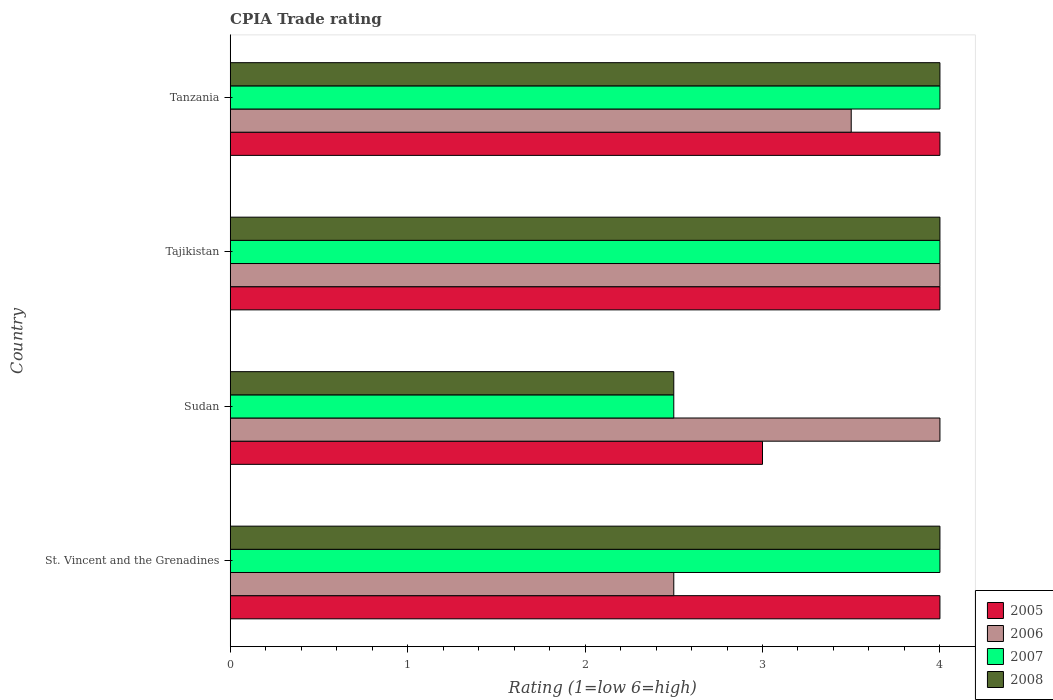How many groups of bars are there?
Give a very brief answer. 4. Are the number of bars per tick equal to the number of legend labels?
Your response must be concise. Yes. Are the number of bars on each tick of the Y-axis equal?
Provide a succinct answer. Yes. How many bars are there on the 1st tick from the bottom?
Offer a very short reply. 4. What is the label of the 3rd group of bars from the top?
Your response must be concise. Sudan. In how many cases, is the number of bars for a given country not equal to the number of legend labels?
Offer a very short reply. 0. What is the CPIA rating in 2007 in Tanzania?
Your response must be concise. 4. Across all countries, what is the maximum CPIA rating in 2007?
Ensure brevity in your answer.  4. In which country was the CPIA rating in 2006 maximum?
Your response must be concise. Sudan. In which country was the CPIA rating in 2005 minimum?
Ensure brevity in your answer.  Sudan. What is the difference between the CPIA rating in 2005 in Tajikistan and that in Tanzania?
Offer a very short reply. 0. What is the difference between the CPIA rating in 2006 in St. Vincent and the Grenadines and the CPIA rating in 2007 in Tanzania?
Offer a terse response. -1.5. What is the average CPIA rating in 2005 per country?
Your answer should be very brief. 3.75. What is the ratio of the CPIA rating in 2005 in Sudan to that in Tajikistan?
Give a very brief answer. 0.75. What is the difference between the highest and the lowest CPIA rating in 2008?
Provide a short and direct response. 1.5. Is it the case that in every country, the sum of the CPIA rating in 2005 and CPIA rating in 2006 is greater than the CPIA rating in 2008?
Give a very brief answer. Yes. How many bars are there?
Offer a terse response. 16. Are all the bars in the graph horizontal?
Provide a succinct answer. Yes. What is the difference between two consecutive major ticks on the X-axis?
Provide a succinct answer. 1. Are the values on the major ticks of X-axis written in scientific E-notation?
Ensure brevity in your answer.  No. Does the graph contain any zero values?
Your answer should be compact. No. How many legend labels are there?
Ensure brevity in your answer.  4. What is the title of the graph?
Provide a succinct answer. CPIA Trade rating. What is the label or title of the X-axis?
Provide a succinct answer. Rating (1=low 6=high). What is the Rating (1=low 6=high) of 2007 in Sudan?
Keep it short and to the point. 2.5. What is the Rating (1=low 6=high) in 2008 in Sudan?
Your response must be concise. 2.5. What is the Rating (1=low 6=high) in 2005 in Tajikistan?
Your response must be concise. 4. What is the Rating (1=low 6=high) of 2007 in Tajikistan?
Offer a terse response. 4. What is the Rating (1=low 6=high) of 2008 in Tajikistan?
Ensure brevity in your answer.  4. What is the Rating (1=low 6=high) in 2008 in Tanzania?
Your answer should be compact. 4. Across all countries, what is the maximum Rating (1=low 6=high) in 2005?
Provide a succinct answer. 4. Across all countries, what is the maximum Rating (1=low 6=high) of 2007?
Your answer should be very brief. 4. Across all countries, what is the minimum Rating (1=low 6=high) of 2006?
Ensure brevity in your answer.  2.5. What is the total Rating (1=low 6=high) of 2005 in the graph?
Provide a short and direct response. 15. What is the total Rating (1=low 6=high) of 2006 in the graph?
Your response must be concise. 14. What is the difference between the Rating (1=low 6=high) in 2006 in St. Vincent and the Grenadines and that in Sudan?
Provide a short and direct response. -1.5. What is the difference between the Rating (1=low 6=high) in 2008 in St. Vincent and the Grenadines and that in Tajikistan?
Make the answer very short. 0. What is the difference between the Rating (1=low 6=high) in 2006 in St. Vincent and the Grenadines and that in Tanzania?
Provide a succinct answer. -1. What is the difference between the Rating (1=low 6=high) of 2007 in St. Vincent and the Grenadines and that in Tanzania?
Offer a terse response. 0. What is the difference between the Rating (1=low 6=high) in 2005 in Sudan and that in Tajikistan?
Provide a short and direct response. -1. What is the difference between the Rating (1=low 6=high) in 2006 in Sudan and that in Tajikistan?
Give a very brief answer. 0. What is the difference between the Rating (1=low 6=high) in 2007 in Sudan and that in Tajikistan?
Provide a short and direct response. -1.5. What is the difference between the Rating (1=low 6=high) in 2008 in Sudan and that in Tajikistan?
Provide a short and direct response. -1.5. What is the difference between the Rating (1=low 6=high) of 2007 in Sudan and that in Tanzania?
Your answer should be very brief. -1.5. What is the difference between the Rating (1=low 6=high) in 2008 in Sudan and that in Tanzania?
Your response must be concise. -1.5. What is the difference between the Rating (1=low 6=high) of 2006 in Tajikistan and that in Tanzania?
Your answer should be compact. 0.5. What is the difference between the Rating (1=low 6=high) in 2007 in Tajikistan and that in Tanzania?
Provide a succinct answer. 0. What is the difference between the Rating (1=low 6=high) of 2008 in Tajikistan and that in Tanzania?
Provide a succinct answer. 0. What is the difference between the Rating (1=low 6=high) in 2005 in St. Vincent and the Grenadines and the Rating (1=low 6=high) in 2008 in Sudan?
Your answer should be compact. 1.5. What is the difference between the Rating (1=low 6=high) of 2006 in St. Vincent and the Grenadines and the Rating (1=low 6=high) of 2007 in Sudan?
Your answer should be very brief. 0. What is the difference between the Rating (1=low 6=high) of 2006 in St. Vincent and the Grenadines and the Rating (1=low 6=high) of 2008 in Sudan?
Make the answer very short. 0. What is the difference between the Rating (1=low 6=high) in 2007 in St. Vincent and the Grenadines and the Rating (1=low 6=high) in 2008 in Sudan?
Ensure brevity in your answer.  1.5. What is the difference between the Rating (1=low 6=high) of 2005 in St. Vincent and the Grenadines and the Rating (1=low 6=high) of 2007 in Tajikistan?
Offer a terse response. 0. What is the difference between the Rating (1=low 6=high) of 2006 in St. Vincent and the Grenadines and the Rating (1=low 6=high) of 2007 in Tajikistan?
Your answer should be compact. -1.5. What is the difference between the Rating (1=low 6=high) in 2005 in St. Vincent and the Grenadines and the Rating (1=low 6=high) in 2006 in Tanzania?
Ensure brevity in your answer.  0.5. What is the difference between the Rating (1=low 6=high) in 2005 in St. Vincent and the Grenadines and the Rating (1=low 6=high) in 2007 in Tanzania?
Give a very brief answer. 0. What is the difference between the Rating (1=low 6=high) of 2006 in St. Vincent and the Grenadines and the Rating (1=low 6=high) of 2007 in Tanzania?
Make the answer very short. -1.5. What is the difference between the Rating (1=low 6=high) in 2006 in St. Vincent and the Grenadines and the Rating (1=low 6=high) in 2008 in Tanzania?
Provide a succinct answer. -1.5. What is the difference between the Rating (1=low 6=high) of 2007 in St. Vincent and the Grenadines and the Rating (1=low 6=high) of 2008 in Tanzania?
Ensure brevity in your answer.  0. What is the difference between the Rating (1=low 6=high) in 2005 in Sudan and the Rating (1=low 6=high) in 2006 in Tajikistan?
Your response must be concise. -1. What is the difference between the Rating (1=low 6=high) in 2005 in Sudan and the Rating (1=low 6=high) in 2007 in Tajikistan?
Give a very brief answer. -1. What is the difference between the Rating (1=low 6=high) in 2006 in Sudan and the Rating (1=low 6=high) in 2007 in Tajikistan?
Your response must be concise. 0. What is the difference between the Rating (1=low 6=high) of 2006 in Sudan and the Rating (1=low 6=high) of 2008 in Tajikistan?
Offer a very short reply. 0. What is the difference between the Rating (1=low 6=high) of 2007 in Sudan and the Rating (1=low 6=high) of 2008 in Tajikistan?
Your answer should be compact. -1.5. What is the difference between the Rating (1=low 6=high) in 2006 in Sudan and the Rating (1=low 6=high) in 2008 in Tanzania?
Your answer should be compact. 0. What is the difference between the Rating (1=low 6=high) in 2005 in Tajikistan and the Rating (1=low 6=high) in 2007 in Tanzania?
Provide a short and direct response. 0. What is the difference between the Rating (1=low 6=high) of 2006 in Tajikistan and the Rating (1=low 6=high) of 2007 in Tanzania?
Provide a succinct answer. 0. What is the difference between the Rating (1=low 6=high) of 2006 in Tajikistan and the Rating (1=low 6=high) of 2008 in Tanzania?
Provide a short and direct response. 0. What is the average Rating (1=low 6=high) in 2005 per country?
Your answer should be very brief. 3.75. What is the average Rating (1=low 6=high) of 2006 per country?
Keep it short and to the point. 3.5. What is the average Rating (1=low 6=high) in 2007 per country?
Your answer should be compact. 3.62. What is the average Rating (1=low 6=high) of 2008 per country?
Offer a terse response. 3.62. What is the difference between the Rating (1=low 6=high) of 2005 and Rating (1=low 6=high) of 2007 in St. Vincent and the Grenadines?
Your answer should be compact. 0. What is the difference between the Rating (1=low 6=high) in 2005 and Rating (1=low 6=high) in 2008 in St. Vincent and the Grenadines?
Ensure brevity in your answer.  0. What is the difference between the Rating (1=low 6=high) in 2007 and Rating (1=low 6=high) in 2008 in St. Vincent and the Grenadines?
Keep it short and to the point. 0. What is the difference between the Rating (1=low 6=high) of 2005 and Rating (1=low 6=high) of 2006 in Sudan?
Provide a short and direct response. -1. What is the difference between the Rating (1=low 6=high) in 2006 and Rating (1=low 6=high) in 2008 in Sudan?
Your answer should be very brief. 1.5. What is the difference between the Rating (1=low 6=high) in 2007 and Rating (1=low 6=high) in 2008 in Sudan?
Offer a very short reply. 0. What is the difference between the Rating (1=low 6=high) in 2005 and Rating (1=low 6=high) in 2007 in Tajikistan?
Make the answer very short. 0. What is the difference between the Rating (1=low 6=high) of 2005 and Rating (1=low 6=high) of 2008 in Tajikistan?
Ensure brevity in your answer.  0. What is the difference between the Rating (1=low 6=high) of 2006 and Rating (1=low 6=high) of 2008 in Tajikistan?
Your response must be concise. 0. What is the difference between the Rating (1=low 6=high) in 2007 and Rating (1=low 6=high) in 2008 in Tajikistan?
Make the answer very short. 0. What is the difference between the Rating (1=low 6=high) in 2005 and Rating (1=low 6=high) in 2006 in Tanzania?
Give a very brief answer. 0.5. What is the difference between the Rating (1=low 6=high) of 2005 and Rating (1=low 6=high) of 2007 in Tanzania?
Your response must be concise. 0. What is the difference between the Rating (1=low 6=high) in 2005 and Rating (1=low 6=high) in 2008 in Tanzania?
Your answer should be very brief. 0. What is the difference between the Rating (1=low 6=high) of 2006 and Rating (1=low 6=high) of 2007 in Tanzania?
Your response must be concise. -0.5. What is the ratio of the Rating (1=low 6=high) in 2005 in St. Vincent and the Grenadines to that in Sudan?
Provide a succinct answer. 1.33. What is the ratio of the Rating (1=low 6=high) of 2006 in St. Vincent and the Grenadines to that in Tajikistan?
Offer a very short reply. 0.62. What is the ratio of the Rating (1=low 6=high) of 2007 in St. Vincent and the Grenadines to that in Tajikistan?
Keep it short and to the point. 1. What is the ratio of the Rating (1=low 6=high) in 2008 in St. Vincent and the Grenadines to that in Tajikistan?
Provide a short and direct response. 1. What is the ratio of the Rating (1=low 6=high) in 2005 in St. Vincent and the Grenadines to that in Tanzania?
Your answer should be very brief. 1. What is the ratio of the Rating (1=low 6=high) of 2007 in St. Vincent and the Grenadines to that in Tanzania?
Ensure brevity in your answer.  1. What is the ratio of the Rating (1=low 6=high) in 2008 in St. Vincent and the Grenadines to that in Tanzania?
Your answer should be compact. 1. What is the ratio of the Rating (1=low 6=high) in 2008 in Sudan to that in Tajikistan?
Give a very brief answer. 0.62. What is the ratio of the Rating (1=low 6=high) in 2005 in Sudan to that in Tanzania?
Keep it short and to the point. 0.75. What is the ratio of the Rating (1=low 6=high) in 2007 in Sudan to that in Tanzania?
Your response must be concise. 0.62. What is the ratio of the Rating (1=low 6=high) of 2008 in Sudan to that in Tanzania?
Offer a terse response. 0.62. What is the ratio of the Rating (1=low 6=high) in 2005 in Tajikistan to that in Tanzania?
Make the answer very short. 1. What is the ratio of the Rating (1=low 6=high) of 2006 in Tajikistan to that in Tanzania?
Your answer should be compact. 1.14. What is the difference between the highest and the lowest Rating (1=low 6=high) of 2007?
Give a very brief answer. 1.5. What is the difference between the highest and the lowest Rating (1=low 6=high) of 2008?
Provide a succinct answer. 1.5. 